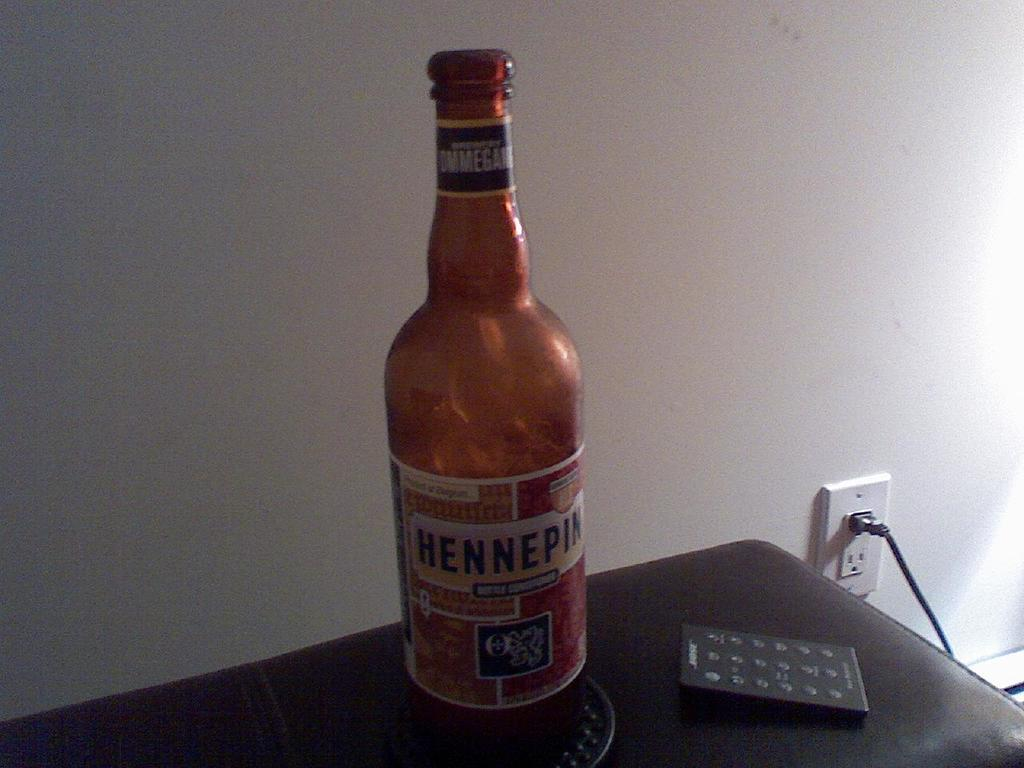Provide a one-sentence caption for the provided image. A bottle of Hennepin beer sitting on a desk. 